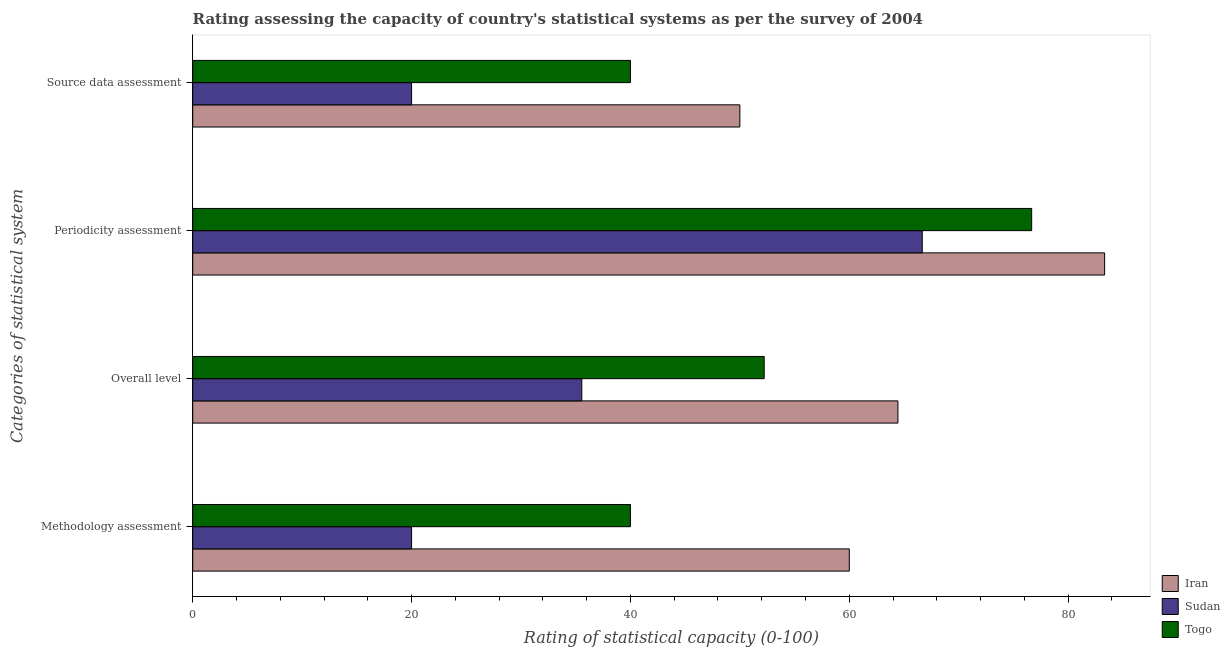How many different coloured bars are there?
Keep it short and to the point. 3. Are the number of bars on each tick of the Y-axis equal?
Provide a short and direct response. Yes. How many bars are there on the 2nd tick from the top?
Keep it short and to the point. 3. What is the label of the 3rd group of bars from the top?
Give a very brief answer. Overall level. What is the periodicity assessment rating in Togo?
Provide a short and direct response. 76.67. Across all countries, what is the minimum periodicity assessment rating?
Provide a succinct answer. 66.67. In which country was the periodicity assessment rating maximum?
Your answer should be very brief. Iran. In which country was the periodicity assessment rating minimum?
Offer a very short reply. Sudan. What is the total overall level rating in the graph?
Provide a short and direct response. 152.22. What is the difference between the overall level rating in Iran and that in Togo?
Make the answer very short. 12.22. What is the difference between the source data assessment rating in Sudan and the overall level rating in Iran?
Offer a very short reply. -44.44. What is the average methodology assessment rating per country?
Your answer should be very brief. 40. What is the difference between the overall level rating and periodicity assessment rating in Sudan?
Provide a succinct answer. -31.11. In how many countries, is the source data assessment rating greater than 28 ?
Provide a short and direct response. 2. What is the ratio of the overall level rating in Iran to that in Togo?
Your response must be concise. 1.23. Is the source data assessment rating in Iran less than that in Sudan?
Your response must be concise. No. Is the difference between the methodology assessment rating in Togo and Sudan greater than the difference between the overall level rating in Togo and Sudan?
Your answer should be very brief. Yes. What is the difference between the highest and the second highest periodicity assessment rating?
Make the answer very short. 6.67. Is the sum of the methodology assessment rating in Togo and Sudan greater than the maximum source data assessment rating across all countries?
Make the answer very short. Yes. What does the 2nd bar from the top in Source data assessment represents?
Provide a short and direct response. Sudan. What does the 2nd bar from the bottom in Periodicity assessment represents?
Offer a terse response. Sudan. How many bars are there?
Offer a terse response. 12. Are all the bars in the graph horizontal?
Your response must be concise. Yes. How many countries are there in the graph?
Make the answer very short. 3. What is the difference between two consecutive major ticks on the X-axis?
Give a very brief answer. 20. Does the graph contain any zero values?
Your answer should be compact. No. Where does the legend appear in the graph?
Offer a very short reply. Bottom right. What is the title of the graph?
Give a very brief answer. Rating assessing the capacity of country's statistical systems as per the survey of 2004 . Does "Bulgaria" appear as one of the legend labels in the graph?
Provide a short and direct response. No. What is the label or title of the X-axis?
Offer a terse response. Rating of statistical capacity (0-100). What is the label or title of the Y-axis?
Offer a very short reply. Categories of statistical system. What is the Rating of statistical capacity (0-100) in Sudan in Methodology assessment?
Your response must be concise. 20. What is the Rating of statistical capacity (0-100) of Togo in Methodology assessment?
Ensure brevity in your answer.  40. What is the Rating of statistical capacity (0-100) of Iran in Overall level?
Your answer should be very brief. 64.44. What is the Rating of statistical capacity (0-100) of Sudan in Overall level?
Your response must be concise. 35.56. What is the Rating of statistical capacity (0-100) in Togo in Overall level?
Keep it short and to the point. 52.22. What is the Rating of statistical capacity (0-100) of Iran in Periodicity assessment?
Offer a very short reply. 83.33. What is the Rating of statistical capacity (0-100) in Sudan in Periodicity assessment?
Your response must be concise. 66.67. What is the Rating of statistical capacity (0-100) in Togo in Periodicity assessment?
Provide a succinct answer. 76.67. What is the Rating of statistical capacity (0-100) in Sudan in Source data assessment?
Make the answer very short. 20. Across all Categories of statistical system, what is the maximum Rating of statistical capacity (0-100) in Iran?
Keep it short and to the point. 83.33. Across all Categories of statistical system, what is the maximum Rating of statistical capacity (0-100) in Sudan?
Your answer should be compact. 66.67. Across all Categories of statistical system, what is the maximum Rating of statistical capacity (0-100) of Togo?
Provide a succinct answer. 76.67. Across all Categories of statistical system, what is the minimum Rating of statistical capacity (0-100) of Togo?
Provide a succinct answer. 40. What is the total Rating of statistical capacity (0-100) of Iran in the graph?
Provide a succinct answer. 257.78. What is the total Rating of statistical capacity (0-100) of Sudan in the graph?
Give a very brief answer. 142.22. What is the total Rating of statistical capacity (0-100) in Togo in the graph?
Make the answer very short. 208.89. What is the difference between the Rating of statistical capacity (0-100) in Iran in Methodology assessment and that in Overall level?
Provide a short and direct response. -4.44. What is the difference between the Rating of statistical capacity (0-100) in Sudan in Methodology assessment and that in Overall level?
Ensure brevity in your answer.  -15.56. What is the difference between the Rating of statistical capacity (0-100) of Togo in Methodology assessment and that in Overall level?
Offer a very short reply. -12.22. What is the difference between the Rating of statistical capacity (0-100) of Iran in Methodology assessment and that in Periodicity assessment?
Offer a terse response. -23.33. What is the difference between the Rating of statistical capacity (0-100) of Sudan in Methodology assessment and that in Periodicity assessment?
Offer a terse response. -46.67. What is the difference between the Rating of statistical capacity (0-100) in Togo in Methodology assessment and that in Periodicity assessment?
Make the answer very short. -36.67. What is the difference between the Rating of statistical capacity (0-100) in Sudan in Methodology assessment and that in Source data assessment?
Provide a short and direct response. 0. What is the difference between the Rating of statistical capacity (0-100) of Iran in Overall level and that in Periodicity assessment?
Offer a very short reply. -18.89. What is the difference between the Rating of statistical capacity (0-100) of Sudan in Overall level and that in Periodicity assessment?
Make the answer very short. -31.11. What is the difference between the Rating of statistical capacity (0-100) of Togo in Overall level and that in Periodicity assessment?
Your response must be concise. -24.44. What is the difference between the Rating of statistical capacity (0-100) in Iran in Overall level and that in Source data assessment?
Provide a short and direct response. 14.44. What is the difference between the Rating of statistical capacity (0-100) in Sudan in Overall level and that in Source data assessment?
Your answer should be compact. 15.56. What is the difference between the Rating of statistical capacity (0-100) of Togo in Overall level and that in Source data assessment?
Provide a short and direct response. 12.22. What is the difference between the Rating of statistical capacity (0-100) in Iran in Periodicity assessment and that in Source data assessment?
Your answer should be very brief. 33.33. What is the difference between the Rating of statistical capacity (0-100) in Sudan in Periodicity assessment and that in Source data assessment?
Give a very brief answer. 46.67. What is the difference between the Rating of statistical capacity (0-100) in Togo in Periodicity assessment and that in Source data assessment?
Keep it short and to the point. 36.67. What is the difference between the Rating of statistical capacity (0-100) of Iran in Methodology assessment and the Rating of statistical capacity (0-100) of Sudan in Overall level?
Ensure brevity in your answer.  24.44. What is the difference between the Rating of statistical capacity (0-100) in Iran in Methodology assessment and the Rating of statistical capacity (0-100) in Togo in Overall level?
Give a very brief answer. 7.78. What is the difference between the Rating of statistical capacity (0-100) in Sudan in Methodology assessment and the Rating of statistical capacity (0-100) in Togo in Overall level?
Give a very brief answer. -32.22. What is the difference between the Rating of statistical capacity (0-100) in Iran in Methodology assessment and the Rating of statistical capacity (0-100) in Sudan in Periodicity assessment?
Your response must be concise. -6.67. What is the difference between the Rating of statistical capacity (0-100) in Iran in Methodology assessment and the Rating of statistical capacity (0-100) in Togo in Periodicity assessment?
Keep it short and to the point. -16.67. What is the difference between the Rating of statistical capacity (0-100) of Sudan in Methodology assessment and the Rating of statistical capacity (0-100) of Togo in Periodicity assessment?
Your answer should be compact. -56.67. What is the difference between the Rating of statistical capacity (0-100) of Iran in Methodology assessment and the Rating of statistical capacity (0-100) of Togo in Source data assessment?
Offer a terse response. 20. What is the difference between the Rating of statistical capacity (0-100) in Iran in Overall level and the Rating of statistical capacity (0-100) in Sudan in Periodicity assessment?
Give a very brief answer. -2.22. What is the difference between the Rating of statistical capacity (0-100) in Iran in Overall level and the Rating of statistical capacity (0-100) in Togo in Periodicity assessment?
Make the answer very short. -12.22. What is the difference between the Rating of statistical capacity (0-100) of Sudan in Overall level and the Rating of statistical capacity (0-100) of Togo in Periodicity assessment?
Provide a short and direct response. -41.11. What is the difference between the Rating of statistical capacity (0-100) in Iran in Overall level and the Rating of statistical capacity (0-100) in Sudan in Source data assessment?
Ensure brevity in your answer.  44.44. What is the difference between the Rating of statistical capacity (0-100) in Iran in Overall level and the Rating of statistical capacity (0-100) in Togo in Source data assessment?
Provide a succinct answer. 24.44. What is the difference between the Rating of statistical capacity (0-100) of Sudan in Overall level and the Rating of statistical capacity (0-100) of Togo in Source data assessment?
Give a very brief answer. -4.44. What is the difference between the Rating of statistical capacity (0-100) in Iran in Periodicity assessment and the Rating of statistical capacity (0-100) in Sudan in Source data assessment?
Your answer should be compact. 63.33. What is the difference between the Rating of statistical capacity (0-100) of Iran in Periodicity assessment and the Rating of statistical capacity (0-100) of Togo in Source data assessment?
Provide a short and direct response. 43.33. What is the difference between the Rating of statistical capacity (0-100) in Sudan in Periodicity assessment and the Rating of statistical capacity (0-100) in Togo in Source data assessment?
Keep it short and to the point. 26.67. What is the average Rating of statistical capacity (0-100) in Iran per Categories of statistical system?
Ensure brevity in your answer.  64.44. What is the average Rating of statistical capacity (0-100) in Sudan per Categories of statistical system?
Your response must be concise. 35.56. What is the average Rating of statistical capacity (0-100) of Togo per Categories of statistical system?
Ensure brevity in your answer.  52.22. What is the difference between the Rating of statistical capacity (0-100) of Iran and Rating of statistical capacity (0-100) of Sudan in Methodology assessment?
Provide a short and direct response. 40. What is the difference between the Rating of statistical capacity (0-100) of Iran and Rating of statistical capacity (0-100) of Togo in Methodology assessment?
Offer a very short reply. 20. What is the difference between the Rating of statistical capacity (0-100) of Sudan and Rating of statistical capacity (0-100) of Togo in Methodology assessment?
Ensure brevity in your answer.  -20. What is the difference between the Rating of statistical capacity (0-100) in Iran and Rating of statistical capacity (0-100) in Sudan in Overall level?
Provide a short and direct response. 28.89. What is the difference between the Rating of statistical capacity (0-100) in Iran and Rating of statistical capacity (0-100) in Togo in Overall level?
Ensure brevity in your answer.  12.22. What is the difference between the Rating of statistical capacity (0-100) in Sudan and Rating of statistical capacity (0-100) in Togo in Overall level?
Offer a very short reply. -16.67. What is the difference between the Rating of statistical capacity (0-100) of Iran and Rating of statistical capacity (0-100) of Sudan in Periodicity assessment?
Make the answer very short. 16.67. What is the difference between the Rating of statistical capacity (0-100) in Iran and Rating of statistical capacity (0-100) in Togo in Periodicity assessment?
Offer a very short reply. 6.67. What is the difference between the Rating of statistical capacity (0-100) in Iran and Rating of statistical capacity (0-100) in Togo in Source data assessment?
Your response must be concise. 10. What is the difference between the Rating of statistical capacity (0-100) in Sudan and Rating of statistical capacity (0-100) in Togo in Source data assessment?
Provide a succinct answer. -20. What is the ratio of the Rating of statistical capacity (0-100) in Iran in Methodology assessment to that in Overall level?
Offer a very short reply. 0.93. What is the ratio of the Rating of statistical capacity (0-100) in Sudan in Methodology assessment to that in Overall level?
Give a very brief answer. 0.56. What is the ratio of the Rating of statistical capacity (0-100) in Togo in Methodology assessment to that in Overall level?
Provide a short and direct response. 0.77. What is the ratio of the Rating of statistical capacity (0-100) of Iran in Methodology assessment to that in Periodicity assessment?
Offer a very short reply. 0.72. What is the ratio of the Rating of statistical capacity (0-100) of Sudan in Methodology assessment to that in Periodicity assessment?
Offer a terse response. 0.3. What is the ratio of the Rating of statistical capacity (0-100) of Togo in Methodology assessment to that in Periodicity assessment?
Keep it short and to the point. 0.52. What is the ratio of the Rating of statistical capacity (0-100) of Sudan in Methodology assessment to that in Source data assessment?
Your answer should be compact. 1. What is the ratio of the Rating of statistical capacity (0-100) of Togo in Methodology assessment to that in Source data assessment?
Your answer should be very brief. 1. What is the ratio of the Rating of statistical capacity (0-100) in Iran in Overall level to that in Periodicity assessment?
Give a very brief answer. 0.77. What is the ratio of the Rating of statistical capacity (0-100) in Sudan in Overall level to that in Periodicity assessment?
Offer a terse response. 0.53. What is the ratio of the Rating of statistical capacity (0-100) in Togo in Overall level to that in Periodicity assessment?
Provide a short and direct response. 0.68. What is the ratio of the Rating of statistical capacity (0-100) in Iran in Overall level to that in Source data assessment?
Ensure brevity in your answer.  1.29. What is the ratio of the Rating of statistical capacity (0-100) in Sudan in Overall level to that in Source data assessment?
Make the answer very short. 1.78. What is the ratio of the Rating of statistical capacity (0-100) in Togo in Overall level to that in Source data assessment?
Your response must be concise. 1.31. What is the ratio of the Rating of statistical capacity (0-100) in Togo in Periodicity assessment to that in Source data assessment?
Your response must be concise. 1.92. What is the difference between the highest and the second highest Rating of statistical capacity (0-100) in Iran?
Offer a very short reply. 18.89. What is the difference between the highest and the second highest Rating of statistical capacity (0-100) in Sudan?
Make the answer very short. 31.11. What is the difference between the highest and the second highest Rating of statistical capacity (0-100) of Togo?
Your response must be concise. 24.44. What is the difference between the highest and the lowest Rating of statistical capacity (0-100) of Iran?
Provide a succinct answer. 33.33. What is the difference between the highest and the lowest Rating of statistical capacity (0-100) in Sudan?
Ensure brevity in your answer.  46.67. What is the difference between the highest and the lowest Rating of statistical capacity (0-100) of Togo?
Your answer should be very brief. 36.67. 